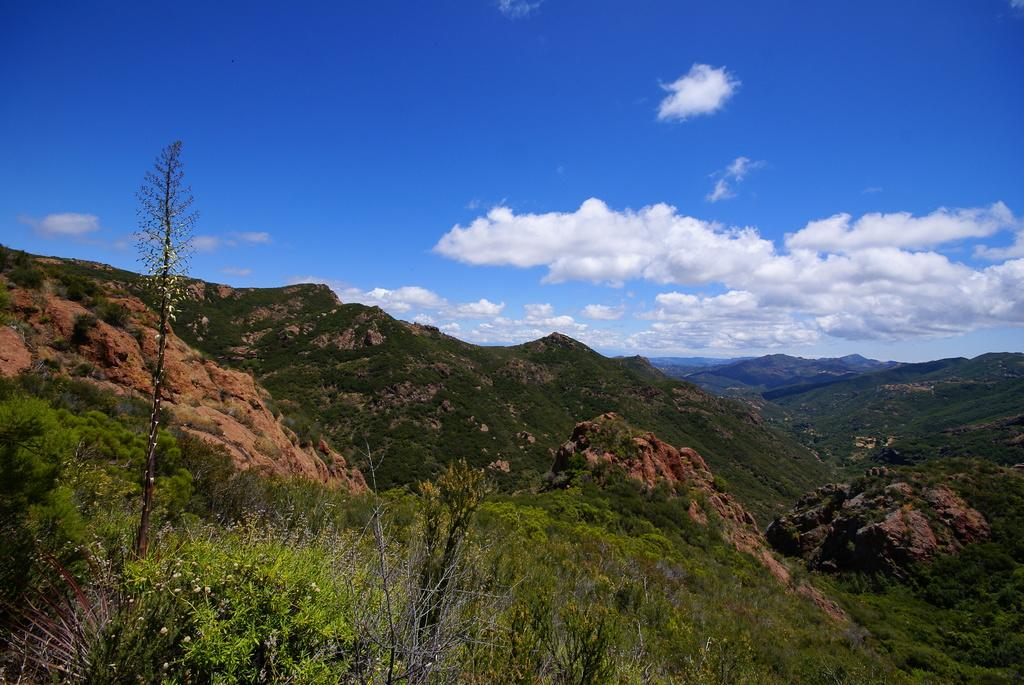What type of setting is depicted in the image? The image is an outside view. What can be seen in the image besides the sky? There are many plants, trees, and hills visible in the image. What is visible at the top of the image? The sky is visible at the top of the image, and clouds are present in the sky. What type of meat is being served at the school in the image? There is no school or meat present in the image. 